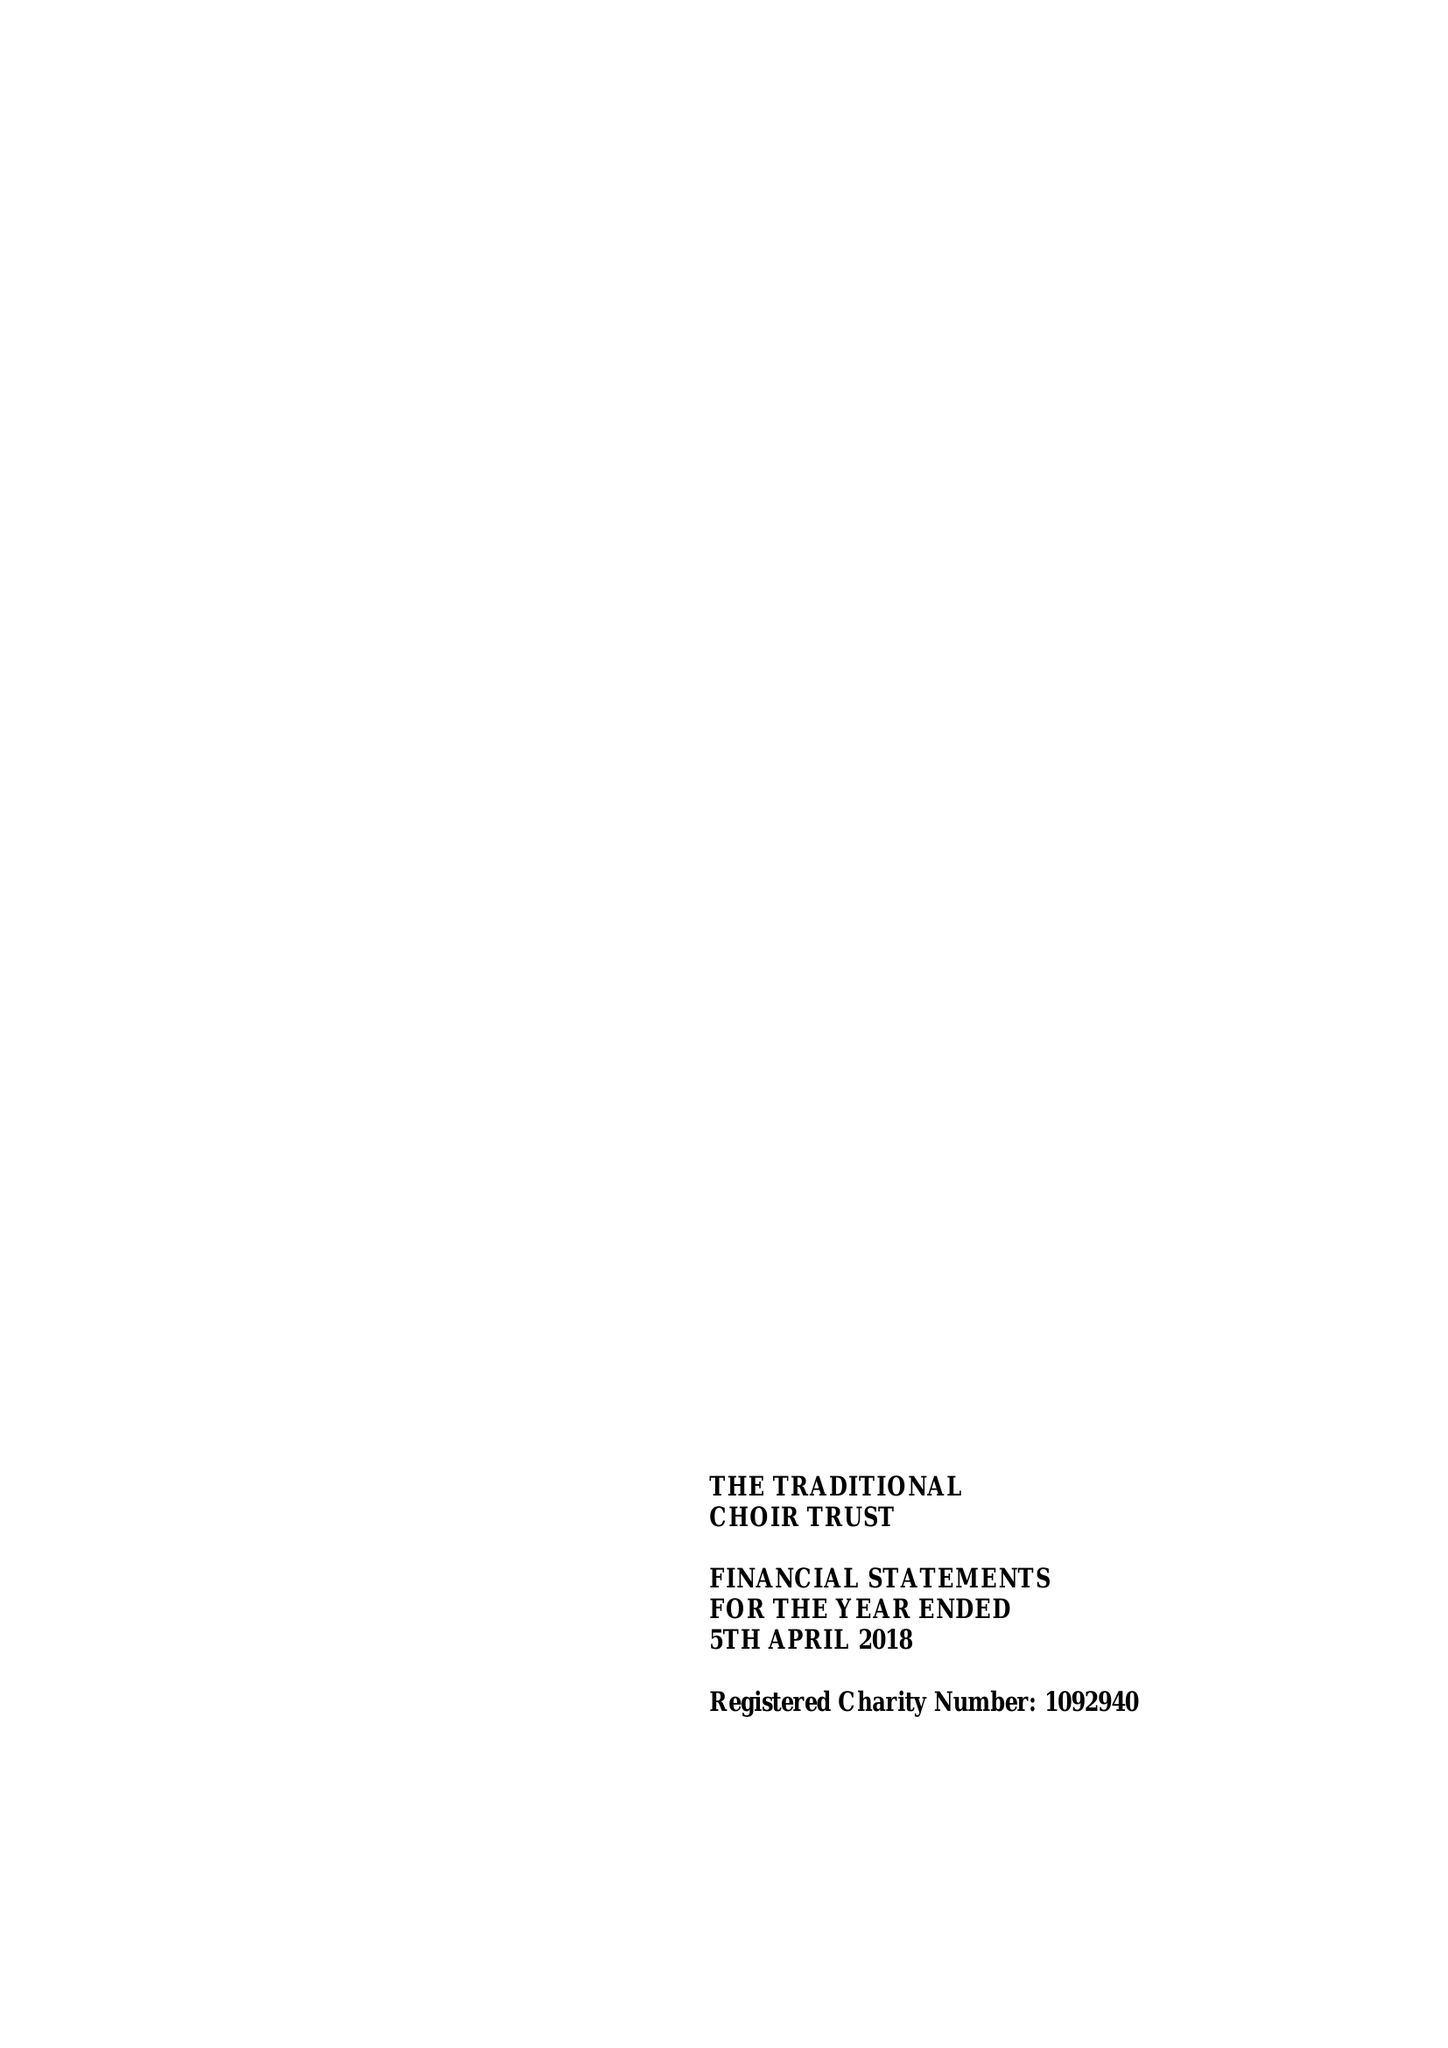What is the value for the spending_annually_in_british_pounds?
Answer the question using a single word or phrase. 18644.00 